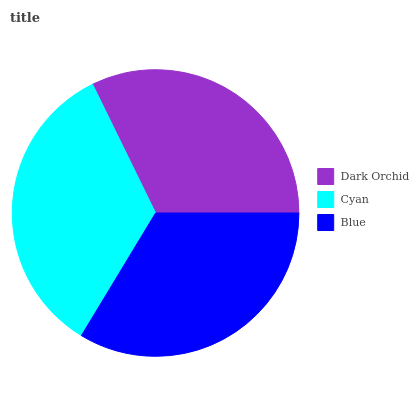Is Dark Orchid the minimum?
Answer yes or no. Yes. Is Cyan the maximum?
Answer yes or no. Yes. Is Blue the minimum?
Answer yes or no. No. Is Blue the maximum?
Answer yes or no. No. Is Cyan greater than Blue?
Answer yes or no. Yes. Is Blue less than Cyan?
Answer yes or no. Yes. Is Blue greater than Cyan?
Answer yes or no. No. Is Cyan less than Blue?
Answer yes or no. No. Is Blue the high median?
Answer yes or no. Yes. Is Blue the low median?
Answer yes or no. Yes. Is Dark Orchid the high median?
Answer yes or no. No. Is Cyan the low median?
Answer yes or no. No. 